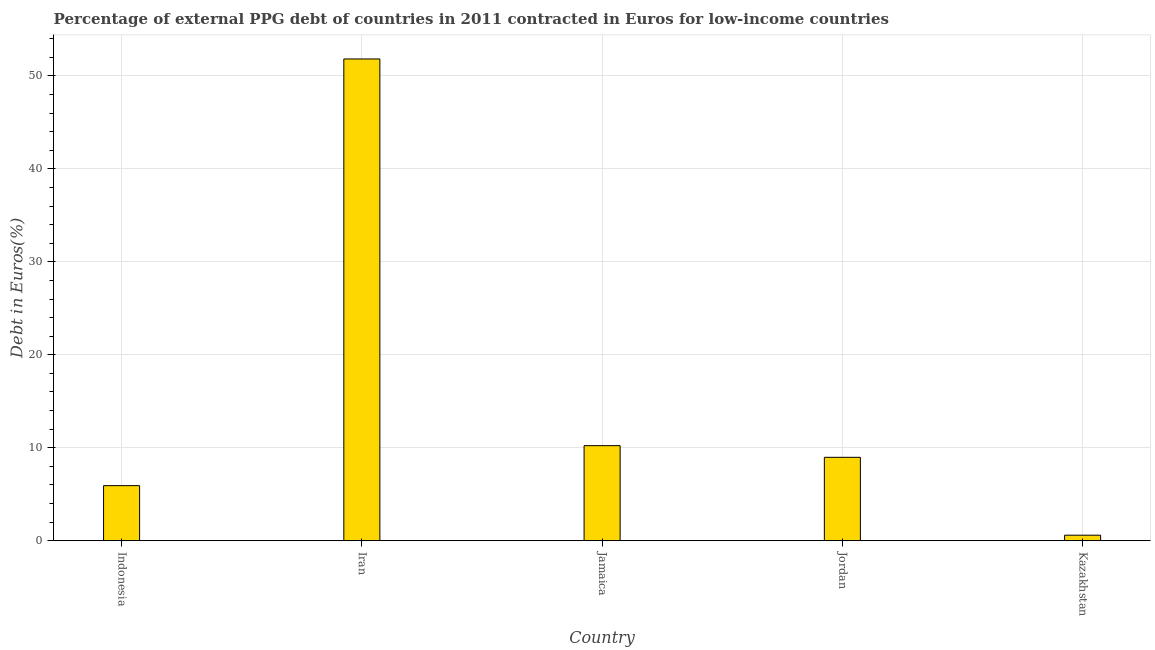Does the graph contain grids?
Ensure brevity in your answer.  Yes. What is the title of the graph?
Make the answer very short. Percentage of external PPG debt of countries in 2011 contracted in Euros for low-income countries. What is the label or title of the X-axis?
Keep it short and to the point. Country. What is the label or title of the Y-axis?
Offer a very short reply. Debt in Euros(%). What is the currency composition of ppg debt in Jamaica?
Give a very brief answer. 10.23. Across all countries, what is the maximum currency composition of ppg debt?
Make the answer very short. 51.83. Across all countries, what is the minimum currency composition of ppg debt?
Provide a short and direct response. 0.59. In which country was the currency composition of ppg debt maximum?
Offer a very short reply. Iran. In which country was the currency composition of ppg debt minimum?
Keep it short and to the point. Kazakhstan. What is the sum of the currency composition of ppg debt?
Your answer should be very brief. 77.55. What is the difference between the currency composition of ppg debt in Indonesia and Jordan?
Your response must be concise. -3.05. What is the average currency composition of ppg debt per country?
Your answer should be compact. 15.51. What is the median currency composition of ppg debt?
Your response must be concise. 8.97. What is the ratio of the currency composition of ppg debt in Jamaica to that in Kazakhstan?
Offer a very short reply. 17.21. Is the currency composition of ppg debt in Jamaica less than that in Kazakhstan?
Provide a short and direct response. No. What is the difference between the highest and the second highest currency composition of ppg debt?
Ensure brevity in your answer.  41.6. Is the sum of the currency composition of ppg debt in Iran and Jamaica greater than the maximum currency composition of ppg debt across all countries?
Ensure brevity in your answer.  Yes. What is the difference between the highest and the lowest currency composition of ppg debt?
Provide a succinct answer. 51.23. In how many countries, is the currency composition of ppg debt greater than the average currency composition of ppg debt taken over all countries?
Provide a short and direct response. 1. Are all the bars in the graph horizontal?
Make the answer very short. No. What is the difference between two consecutive major ticks on the Y-axis?
Offer a terse response. 10. What is the Debt in Euros(%) of Indonesia?
Make the answer very short. 5.92. What is the Debt in Euros(%) in Iran?
Your answer should be very brief. 51.83. What is the Debt in Euros(%) in Jamaica?
Give a very brief answer. 10.23. What is the Debt in Euros(%) of Jordan?
Offer a terse response. 8.97. What is the Debt in Euros(%) in Kazakhstan?
Provide a succinct answer. 0.59. What is the difference between the Debt in Euros(%) in Indonesia and Iran?
Provide a succinct answer. -45.9. What is the difference between the Debt in Euros(%) in Indonesia and Jamaica?
Give a very brief answer. -4.3. What is the difference between the Debt in Euros(%) in Indonesia and Jordan?
Provide a short and direct response. -3.05. What is the difference between the Debt in Euros(%) in Indonesia and Kazakhstan?
Keep it short and to the point. 5.33. What is the difference between the Debt in Euros(%) in Iran and Jamaica?
Keep it short and to the point. 41.6. What is the difference between the Debt in Euros(%) in Iran and Jordan?
Give a very brief answer. 42.86. What is the difference between the Debt in Euros(%) in Iran and Kazakhstan?
Offer a very short reply. 51.23. What is the difference between the Debt in Euros(%) in Jamaica and Jordan?
Your answer should be compact. 1.25. What is the difference between the Debt in Euros(%) in Jamaica and Kazakhstan?
Give a very brief answer. 9.63. What is the difference between the Debt in Euros(%) in Jordan and Kazakhstan?
Your answer should be compact. 8.38. What is the ratio of the Debt in Euros(%) in Indonesia to that in Iran?
Make the answer very short. 0.11. What is the ratio of the Debt in Euros(%) in Indonesia to that in Jamaica?
Offer a terse response. 0.58. What is the ratio of the Debt in Euros(%) in Indonesia to that in Jordan?
Offer a terse response. 0.66. What is the ratio of the Debt in Euros(%) in Indonesia to that in Kazakhstan?
Your response must be concise. 9.97. What is the ratio of the Debt in Euros(%) in Iran to that in Jamaica?
Make the answer very short. 5.07. What is the ratio of the Debt in Euros(%) in Iran to that in Jordan?
Offer a very short reply. 5.78. What is the ratio of the Debt in Euros(%) in Iran to that in Kazakhstan?
Provide a short and direct response. 87.21. What is the ratio of the Debt in Euros(%) in Jamaica to that in Jordan?
Give a very brief answer. 1.14. What is the ratio of the Debt in Euros(%) in Jamaica to that in Kazakhstan?
Provide a short and direct response. 17.21. What is the ratio of the Debt in Euros(%) in Jordan to that in Kazakhstan?
Provide a succinct answer. 15.1. 